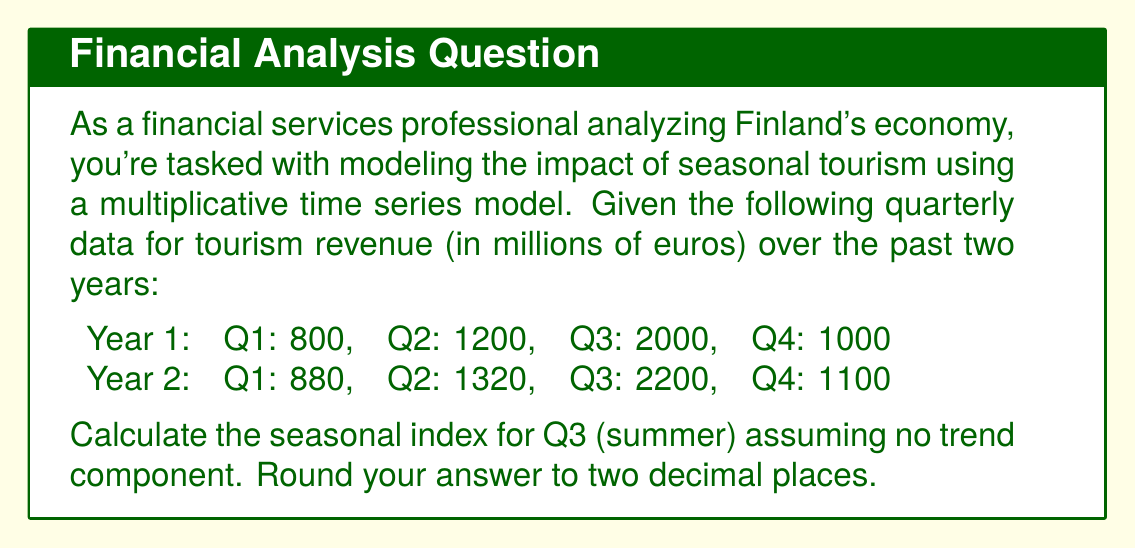Teach me how to tackle this problem. To calculate the seasonal index for Q3 using a multiplicative time series model without a trend component, we'll follow these steps:

1. Calculate the average for each quarter across both years:
   Q1 average: $\frac{800 + 880}{2} = 840$
   Q2 average: $\frac{1200 + 1320}{2} = 1260$
   Q3 average: $\frac{2000 + 2200}{2} = 2100$
   Q4 average: $\frac{1000 + 1100}{2} = 1050$

2. Calculate the overall average across all quarters:
   $\frac{840 + 1260 + 2100 + 1050}{4} = 1312.5$

3. Calculate the seasonal index for Q3:
   Seasonal Index (Q3) = $\frac{\text{Q3 average}}{\text{Overall average}}$
   
   $\text{Seasonal Index (Q3)} = \frac{2100}{1312.5} = 1.6$

4. Round the result to two decimal places:
   Seasonal Index (Q3) = 1.60

This index indicates that Q3 (summer) tourism revenue is typically 60% higher than the average quarter, reflecting the strong seasonal impact of summer tourism on Finland's economy.
Answer: 1.60 